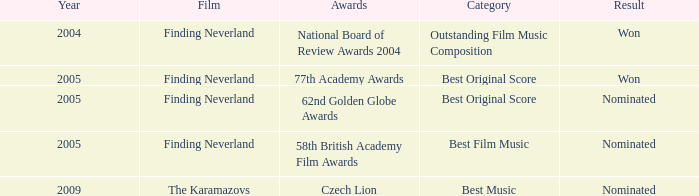What was the result for years prior to 2005? Won. 